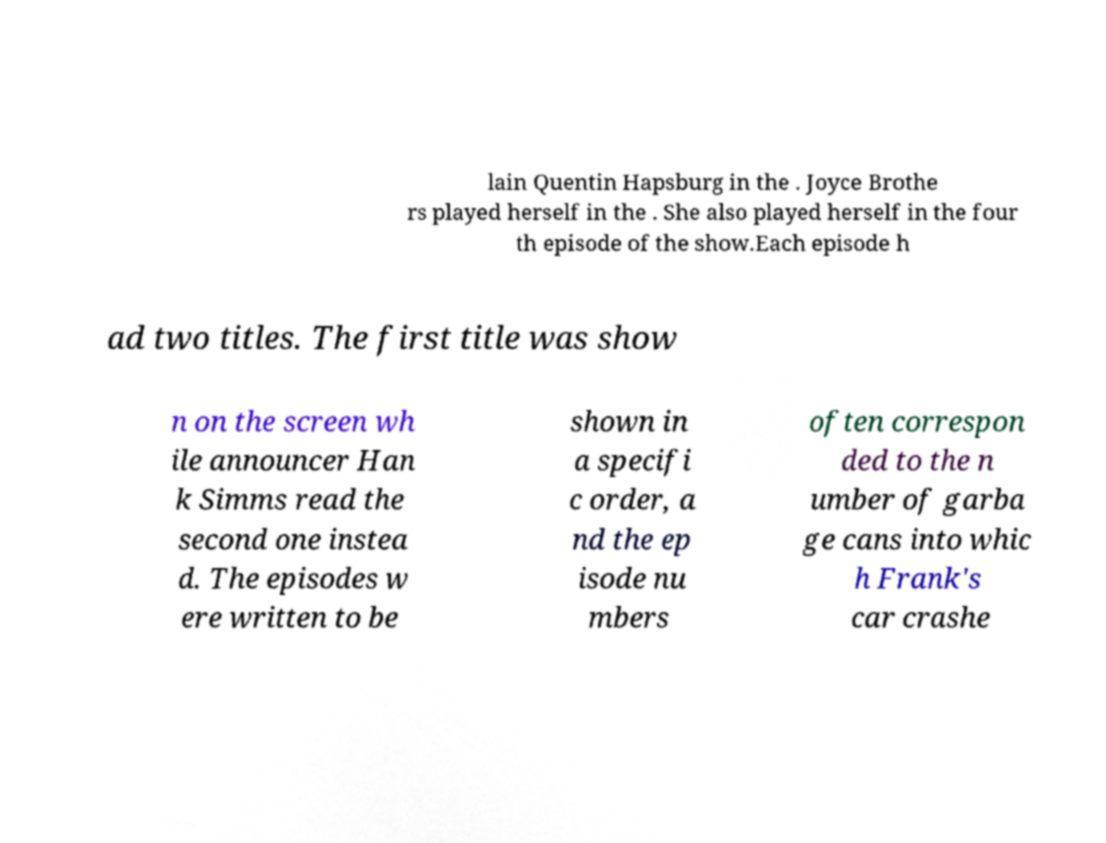Could you assist in decoding the text presented in this image and type it out clearly? lain Quentin Hapsburg in the . Joyce Brothe rs played herself in the . She also played herself in the four th episode of the show.Each episode h ad two titles. The first title was show n on the screen wh ile announcer Han k Simms read the second one instea d. The episodes w ere written to be shown in a specifi c order, a nd the ep isode nu mbers often correspon ded to the n umber of garba ge cans into whic h Frank's car crashe 